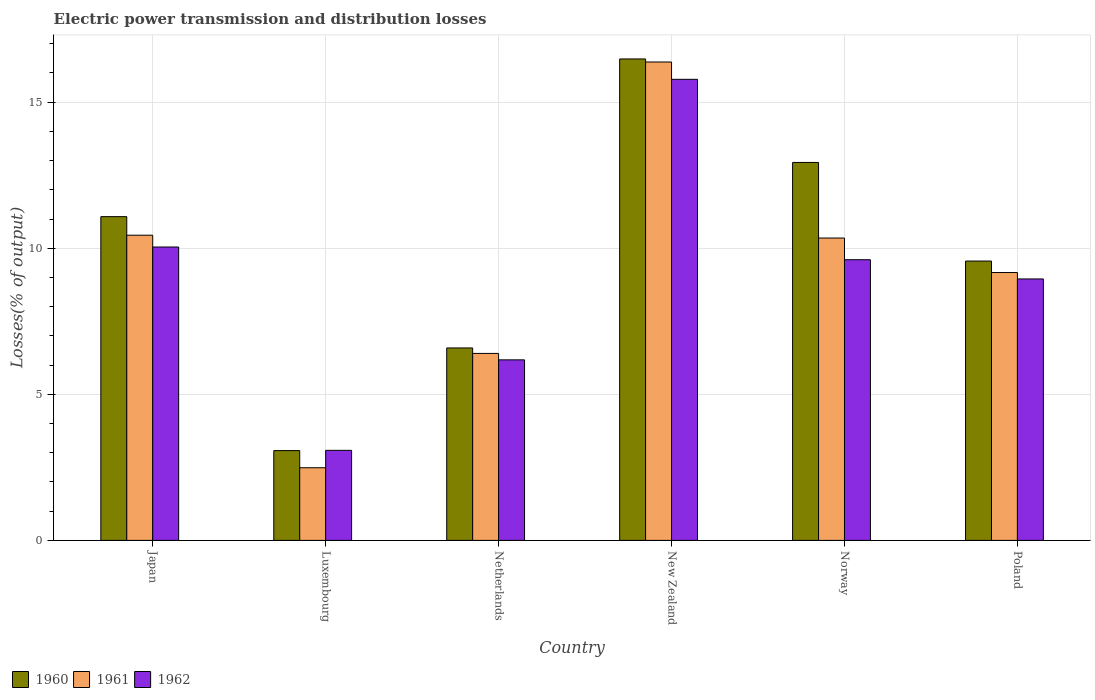How many different coloured bars are there?
Your answer should be compact. 3. How many groups of bars are there?
Make the answer very short. 6. Are the number of bars per tick equal to the number of legend labels?
Your response must be concise. Yes. How many bars are there on the 2nd tick from the left?
Ensure brevity in your answer.  3. How many bars are there on the 2nd tick from the right?
Your answer should be very brief. 3. What is the label of the 3rd group of bars from the left?
Your response must be concise. Netherlands. In how many cases, is the number of bars for a given country not equal to the number of legend labels?
Offer a very short reply. 0. What is the electric power transmission and distribution losses in 1962 in Luxembourg?
Make the answer very short. 3.08. Across all countries, what is the maximum electric power transmission and distribution losses in 1960?
Provide a succinct answer. 16.48. Across all countries, what is the minimum electric power transmission and distribution losses in 1961?
Your response must be concise. 2.49. In which country was the electric power transmission and distribution losses in 1960 maximum?
Your answer should be very brief. New Zealand. In which country was the electric power transmission and distribution losses in 1961 minimum?
Your answer should be very brief. Luxembourg. What is the total electric power transmission and distribution losses in 1962 in the graph?
Offer a terse response. 53.65. What is the difference between the electric power transmission and distribution losses in 1961 in Japan and that in Netherlands?
Keep it short and to the point. 4.05. What is the difference between the electric power transmission and distribution losses in 1961 in Norway and the electric power transmission and distribution losses in 1962 in Poland?
Offer a very short reply. 1.4. What is the average electric power transmission and distribution losses in 1961 per country?
Provide a succinct answer. 9.2. What is the difference between the electric power transmission and distribution losses of/in 1962 and electric power transmission and distribution losses of/in 1961 in Japan?
Your response must be concise. -0.4. What is the ratio of the electric power transmission and distribution losses in 1961 in Japan to that in Poland?
Give a very brief answer. 1.14. Is the electric power transmission and distribution losses in 1961 in Japan less than that in Netherlands?
Your answer should be very brief. No. What is the difference between the highest and the second highest electric power transmission and distribution losses in 1961?
Offer a terse response. 5.93. What is the difference between the highest and the lowest electric power transmission and distribution losses in 1960?
Give a very brief answer. 13.41. What does the 1st bar from the left in New Zealand represents?
Provide a succinct answer. 1960. What does the 1st bar from the right in New Zealand represents?
Keep it short and to the point. 1962. How many bars are there?
Keep it short and to the point. 18. How many countries are there in the graph?
Offer a terse response. 6. What is the difference between two consecutive major ticks on the Y-axis?
Make the answer very short. 5. Are the values on the major ticks of Y-axis written in scientific E-notation?
Your response must be concise. No. Does the graph contain grids?
Give a very brief answer. Yes. What is the title of the graph?
Your answer should be very brief. Electric power transmission and distribution losses. Does "1999" appear as one of the legend labels in the graph?
Your answer should be very brief. No. What is the label or title of the Y-axis?
Your answer should be compact. Losses(% of output). What is the Losses(% of output) of 1960 in Japan?
Your answer should be very brief. 11.08. What is the Losses(% of output) in 1961 in Japan?
Ensure brevity in your answer.  10.45. What is the Losses(% of output) in 1962 in Japan?
Your response must be concise. 10.04. What is the Losses(% of output) of 1960 in Luxembourg?
Your answer should be compact. 3.07. What is the Losses(% of output) of 1961 in Luxembourg?
Your answer should be very brief. 2.49. What is the Losses(% of output) of 1962 in Luxembourg?
Provide a succinct answer. 3.08. What is the Losses(% of output) in 1960 in Netherlands?
Your response must be concise. 6.59. What is the Losses(% of output) of 1961 in Netherlands?
Provide a succinct answer. 6.4. What is the Losses(% of output) of 1962 in Netherlands?
Make the answer very short. 6.18. What is the Losses(% of output) in 1960 in New Zealand?
Make the answer very short. 16.48. What is the Losses(% of output) in 1961 in New Zealand?
Offer a terse response. 16.38. What is the Losses(% of output) in 1962 in New Zealand?
Provide a short and direct response. 15.78. What is the Losses(% of output) of 1960 in Norway?
Offer a very short reply. 12.94. What is the Losses(% of output) in 1961 in Norway?
Offer a terse response. 10.35. What is the Losses(% of output) of 1962 in Norway?
Your answer should be very brief. 9.61. What is the Losses(% of output) of 1960 in Poland?
Provide a succinct answer. 9.56. What is the Losses(% of output) in 1961 in Poland?
Your answer should be compact. 9.17. What is the Losses(% of output) of 1962 in Poland?
Keep it short and to the point. 8.95. Across all countries, what is the maximum Losses(% of output) in 1960?
Offer a terse response. 16.48. Across all countries, what is the maximum Losses(% of output) of 1961?
Your response must be concise. 16.38. Across all countries, what is the maximum Losses(% of output) in 1962?
Your answer should be very brief. 15.78. Across all countries, what is the minimum Losses(% of output) of 1960?
Keep it short and to the point. 3.07. Across all countries, what is the minimum Losses(% of output) of 1961?
Keep it short and to the point. 2.49. Across all countries, what is the minimum Losses(% of output) in 1962?
Your answer should be compact. 3.08. What is the total Losses(% of output) of 1960 in the graph?
Your answer should be compact. 59.72. What is the total Losses(% of output) in 1961 in the graph?
Make the answer very short. 55.23. What is the total Losses(% of output) in 1962 in the graph?
Provide a short and direct response. 53.65. What is the difference between the Losses(% of output) in 1960 in Japan and that in Luxembourg?
Offer a terse response. 8.01. What is the difference between the Losses(% of output) of 1961 in Japan and that in Luxembourg?
Your answer should be compact. 7.96. What is the difference between the Losses(% of output) in 1962 in Japan and that in Luxembourg?
Give a very brief answer. 6.96. What is the difference between the Losses(% of output) in 1960 in Japan and that in Netherlands?
Provide a succinct answer. 4.49. What is the difference between the Losses(% of output) of 1961 in Japan and that in Netherlands?
Offer a very short reply. 4.05. What is the difference between the Losses(% of output) in 1962 in Japan and that in Netherlands?
Make the answer very short. 3.86. What is the difference between the Losses(% of output) of 1960 in Japan and that in New Zealand?
Make the answer very short. -5.4. What is the difference between the Losses(% of output) in 1961 in Japan and that in New Zealand?
Keep it short and to the point. -5.93. What is the difference between the Losses(% of output) in 1962 in Japan and that in New Zealand?
Ensure brevity in your answer.  -5.74. What is the difference between the Losses(% of output) in 1960 in Japan and that in Norway?
Make the answer very short. -1.85. What is the difference between the Losses(% of output) of 1961 in Japan and that in Norway?
Give a very brief answer. 0.1. What is the difference between the Losses(% of output) of 1962 in Japan and that in Norway?
Give a very brief answer. 0.44. What is the difference between the Losses(% of output) in 1960 in Japan and that in Poland?
Your answer should be very brief. 1.52. What is the difference between the Losses(% of output) of 1961 in Japan and that in Poland?
Ensure brevity in your answer.  1.28. What is the difference between the Losses(% of output) of 1962 in Japan and that in Poland?
Keep it short and to the point. 1.09. What is the difference between the Losses(% of output) in 1960 in Luxembourg and that in Netherlands?
Ensure brevity in your answer.  -3.51. What is the difference between the Losses(% of output) in 1961 in Luxembourg and that in Netherlands?
Offer a terse response. -3.91. What is the difference between the Losses(% of output) of 1962 in Luxembourg and that in Netherlands?
Provide a succinct answer. -3.1. What is the difference between the Losses(% of output) in 1960 in Luxembourg and that in New Zealand?
Your answer should be compact. -13.41. What is the difference between the Losses(% of output) in 1961 in Luxembourg and that in New Zealand?
Offer a very short reply. -13.89. What is the difference between the Losses(% of output) in 1962 in Luxembourg and that in New Zealand?
Offer a terse response. -12.7. What is the difference between the Losses(% of output) of 1960 in Luxembourg and that in Norway?
Offer a terse response. -9.86. What is the difference between the Losses(% of output) of 1961 in Luxembourg and that in Norway?
Offer a terse response. -7.86. What is the difference between the Losses(% of output) of 1962 in Luxembourg and that in Norway?
Your answer should be very brief. -6.53. What is the difference between the Losses(% of output) of 1960 in Luxembourg and that in Poland?
Your answer should be very brief. -6.49. What is the difference between the Losses(% of output) of 1961 in Luxembourg and that in Poland?
Offer a terse response. -6.68. What is the difference between the Losses(% of output) in 1962 in Luxembourg and that in Poland?
Your answer should be very brief. -5.87. What is the difference between the Losses(% of output) in 1960 in Netherlands and that in New Zealand?
Your response must be concise. -9.89. What is the difference between the Losses(% of output) of 1961 in Netherlands and that in New Zealand?
Your answer should be very brief. -9.98. What is the difference between the Losses(% of output) of 1962 in Netherlands and that in New Zealand?
Give a very brief answer. -9.6. What is the difference between the Losses(% of output) in 1960 in Netherlands and that in Norway?
Make the answer very short. -6.35. What is the difference between the Losses(% of output) in 1961 in Netherlands and that in Norway?
Your answer should be compact. -3.95. What is the difference between the Losses(% of output) of 1962 in Netherlands and that in Norway?
Offer a very short reply. -3.43. What is the difference between the Losses(% of output) in 1960 in Netherlands and that in Poland?
Give a very brief answer. -2.97. What is the difference between the Losses(% of output) of 1961 in Netherlands and that in Poland?
Offer a very short reply. -2.77. What is the difference between the Losses(% of output) of 1962 in Netherlands and that in Poland?
Ensure brevity in your answer.  -2.77. What is the difference between the Losses(% of output) in 1960 in New Zealand and that in Norway?
Give a very brief answer. 3.54. What is the difference between the Losses(% of output) in 1961 in New Zealand and that in Norway?
Give a very brief answer. 6.03. What is the difference between the Losses(% of output) of 1962 in New Zealand and that in Norway?
Make the answer very short. 6.18. What is the difference between the Losses(% of output) of 1960 in New Zealand and that in Poland?
Your answer should be compact. 6.92. What is the difference between the Losses(% of output) of 1961 in New Zealand and that in Poland?
Offer a terse response. 7.21. What is the difference between the Losses(% of output) in 1962 in New Zealand and that in Poland?
Make the answer very short. 6.83. What is the difference between the Losses(% of output) in 1960 in Norway and that in Poland?
Offer a terse response. 3.38. What is the difference between the Losses(% of output) of 1961 in Norway and that in Poland?
Offer a terse response. 1.18. What is the difference between the Losses(% of output) in 1962 in Norway and that in Poland?
Offer a terse response. 0.66. What is the difference between the Losses(% of output) in 1960 in Japan and the Losses(% of output) in 1961 in Luxembourg?
Your answer should be very brief. 8.6. What is the difference between the Losses(% of output) of 1960 in Japan and the Losses(% of output) of 1962 in Luxembourg?
Give a very brief answer. 8. What is the difference between the Losses(% of output) in 1961 in Japan and the Losses(% of output) in 1962 in Luxembourg?
Offer a terse response. 7.36. What is the difference between the Losses(% of output) in 1960 in Japan and the Losses(% of output) in 1961 in Netherlands?
Offer a very short reply. 4.68. What is the difference between the Losses(% of output) in 1960 in Japan and the Losses(% of output) in 1962 in Netherlands?
Offer a very short reply. 4.9. What is the difference between the Losses(% of output) of 1961 in Japan and the Losses(% of output) of 1962 in Netherlands?
Keep it short and to the point. 4.27. What is the difference between the Losses(% of output) of 1960 in Japan and the Losses(% of output) of 1961 in New Zealand?
Your response must be concise. -5.29. What is the difference between the Losses(% of output) in 1960 in Japan and the Losses(% of output) in 1962 in New Zealand?
Provide a short and direct response. -4.7. What is the difference between the Losses(% of output) in 1961 in Japan and the Losses(% of output) in 1962 in New Zealand?
Your answer should be compact. -5.34. What is the difference between the Losses(% of output) in 1960 in Japan and the Losses(% of output) in 1961 in Norway?
Offer a terse response. 0.73. What is the difference between the Losses(% of output) in 1960 in Japan and the Losses(% of output) in 1962 in Norway?
Give a very brief answer. 1.47. What is the difference between the Losses(% of output) in 1961 in Japan and the Losses(% of output) in 1962 in Norway?
Provide a short and direct response. 0.84. What is the difference between the Losses(% of output) of 1960 in Japan and the Losses(% of output) of 1961 in Poland?
Offer a terse response. 1.91. What is the difference between the Losses(% of output) of 1960 in Japan and the Losses(% of output) of 1962 in Poland?
Give a very brief answer. 2.13. What is the difference between the Losses(% of output) in 1961 in Japan and the Losses(% of output) in 1962 in Poland?
Your response must be concise. 1.5. What is the difference between the Losses(% of output) of 1960 in Luxembourg and the Losses(% of output) of 1961 in Netherlands?
Provide a succinct answer. -3.33. What is the difference between the Losses(% of output) in 1960 in Luxembourg and the Losses(% of output) in 1962 in Netherlands?
Give a very brief answer. -3.11. What is the difference between the Losses(% of output) in 1961 in Luxembourg and the Losses(% of output) in 1962 in Netherlands?
Ensure brevity in your answer.  -3.69. What is the difference between the Losses(% of output) in 1960 in Luxembourg and the Losses(% of output) in 1961 in New Zealand?
Keep it short and to the point. -13.3. What is the difference between the Losses(% of output) in 1960 in Luxembourg and the Losses(% of output) in 1962 in New Zealand?
Make the answer very short. -12.71. What is the difference between the Losses(% of output) in 1961 in Luxembourg and the Losses(% of output) in 1962 in New Zealand?
Provide a succinct answer. -13.3. What is the difference between the Losses(% of output) of 1960 in Luxembourg and the Losses(% of output) of 1961 in Norway?
Provide a short and direct response. -7.28. What is the difference between the Losses(% of output) of 1960 in Luxembourg and the Losses(% of output) of 1962 in Norway?
Provide a short and direct response. -6.53. What is the difference between the Losses(% of output) in 1961 in Luxembourg and the Losses(% of output) in 1962 in Norway?
Your answer should be compact. -7.12. What is the difference between the Losses(% of output) of 1960 in Luxembourg and the Losses(% of output) of 1961 in Poland?
Give a very brief answer. -6.09. What is the difference between the Losses(% of output) in 1960 in Luxembourg and the Losses(% of output) in 1962 in Poland?
Keep it short and to the point. -5.88. What is the difference between the Losses(% of output) in 1961 in Luxembourg and the Losses(% of output) in 1962 in Poland?
Give a very brief answer. -6.46. What is the difference between the Losses(% of output) in 1960 in Netherlands and the Losses(% of output) in 1961 in New Zealand?
Give a very brief answer. -9.79. What is the difference between the Losses(% of output) in 1960 in Netherlands and the Losses(% of output) in 1962 in New Zealand?
Provide a short and direct response. -9.2. What is the difference between the Losses(% of output) in 1961 in Netherlands and the Losses(% of output) in 1962 in New Zealand?
Offer a terse response. -9.38. What is the difference between the Losses(% of output) in 1960 in Netherlands and the Losses(% of output) in 1961 in Norway?
Offer a terse response. -3.76. What is the difference between the Losses(% of output) of 1960 in Netherlands and the Losses(% of output) of 1962 in Norway?
Give a very brief answer. -3.02. What is the difference between the Losses(% of output) in 1961 in Netherlands and the Losses(% of output) in 1962 in Norway?
Provide a short and direct response. -3.21. What is the difference between the Losses(% of output) of 1960 in Netherlands and the Losses(% of output) of 1961 in Poland?
Provide a short and direct response. -2.58. What is the difference between the Losses(% of output) in 1960 in Netherlands and the Losses(% of output) in 1962 in Poland?
Provide a short and direct response. -2.36. What is the difference between the Losses(% of output) of 1961 in Netherlands and the Losses(% of output) of 1962 in Poland?
Your answer should be compact. -2.55. What is the difference between the Losses(% of output) of 1960 in New Zealand and the Losses(% of output) of 1961 in Norway?
Ensure brevity in your answer.  6.13. What is the difference between the Losses(% of output) of 1960 in New Zealand and the Losses(% of output) of 1962 in Norway?
Make the answer very short. 6.87. What is the difference between the Losses(% of output) of 1961 in New Zealand and the Losses(% of output) of 1962 in Norway?
Offer a very short reply. 6.77. What is the difference between the Losses(% of output) in 1960 in New Zealand and the Losses(% of output) in 1961 in Poland?
Make the answer very short. 7.31. What is the difference between the Losses(% of output) in 1960 in New Zealand and the Losses(% of output) in 1962 in Poland?
Your answer should be compact. 7.53. What is the difference between the Losses(% of output) in 1961 in New Zealand and the Losses(% of output) in 1962 in Poland?
Offer a very short reply. 7.43. What is the difference between the Losses(% of output) in 1960 in Norway and the Losses(% of output) in 1961 in Poland?
Your response must be concise. 3.77. What is the difference between the Losses(% of output) of 1960 in Norway and the Losses(% of output) of 1962 in Poland?
Keep it short and to the point. 3.99. What is the difference between the Losses(% of output) of 1961 in Norway and the Losses(% of output) of 1962 in Poland?
Give a very brief answer. 1.4. What is the average Losses(% of output) in 1960 per country?
Your answer should be compact. 9.95. What is the average Losses(% of output) of 1961 per country?
Ensure brevity in your answer.  9.2. What is the average Losses(% of output) in 1962 per country?
Provide a succinct answer. 8.94. What is the difference between the Losses(% of output) of 1960 and Losses(% of output) of 1961 in Japan?
Make the answer very short. 0.64. What is the difference between the Losses(% of output) in 1960 and Losses(% of output) in 1962 in Japan?
Provide a succinct answer. 1.04. What is the difference between the Losses(% of output) in 1961 and Losses(% of output) in 1962 in Japan?
Ensure brevity in your answer.  0.4. What is the difference between the Losses(% of output) of 1960 and Losses(% of output) of 1961 in Luxembourg?
Ensure brevity in your answer.  0.59. What is the difference between the Losses(% of output) in 1960 and Losses(% of output) in 1962 in Luxembourg?
Provide a succinct answer. -0.01. What is the difference between the Losses(% of output) in 1961 and Losses(% of output) in 1962 in Luxembourg?
Offer a terse response. -0.6. What is the difference between the Losses(% of output) of 1960 and Losses(% of output) of 1961 in Netherlands?
Your response must be concise. 0.19. What is the difference between the Losses(% of output) in 1960 and Losses(% of output) in 1962 in Netherlands?
Your answer should be compact. 0.41. What is the difference between the Losses(% of output) of 1961 and Losses(% of output) of 1962 in Netherlands?
Ensure brevity in your answer.  0.22. What is the difference between the Losses(% of output) of 1960 and Losses(% of output) of 1961 in New Zealand?
Your answer should be compact. 0.1. What is the difference between the Losses(% of output) in 1960 and Losses(% of output) in 1962 in New Zealand?
Offer a very short reply. 0.7. What is the difference between the Losses(% of output) in 1961 and Losses(% of output) in 1962 in New Zealand?
Give a very brief answer. 0.59. What is the difference between the Losses(% of output) in 1960 and Losses(% of output) in 1961 in Norway?
Provide a succinct answer. 2.59. What is the difference between the Losses(% of output) in 1960 and Losses(% of output) in 1962 in Norway?
Provide a short and direct response. 3.33. What is the difference between the Losses(% of output) of 1961 and Losses(% of output) of 1962 in Norway?
Offer a very short reply. 0.74. What is the difference between the Losses(% of output) in 1960 and Losses(% of output) in 1961 in Poland?
Offer a very short reply. 0.39. What is the difference between the Losses(% of output) of 1960 and Losses(% of output) of 1962 in Poland?
Your answer should be compact. 0.61. What is the difference between the Losses(% of output) in 1961 and Losses(% of output) in 1962 in Poland?
Offer a terse response. 0.22. What is the ratio of the Losses(% of output) in 1960 in Japan to that in Luxembourg?
Your answer should be compact. 3.61. What is the ratio of the Losses(% of output) of 1961 in Japan to that in Luxembourg?
Make the answer very short. 4.2. What is the ratio of the Losses(% of output) of 1962 in Japan to that in Luxembourg?
Your answer should be compact. 3.26. What is the ratio of the Losses(% of output) of 1960 in Japan to that in Netherlands?
Ensure brevity in your answer.  1.68. What is the ratio of the Losses(% of output) in 1961 in Japan to that in Netherlands?
Keep it short and to the point. 1.63. What is the ratio of the Losses(% of output) in 1962 in Japan to that in Netherlands?
Offer a very short reply. 1.62. What is the ratio of the Losses(% of output) in 1960 in Japan to that in New Zealand?
Provide a short and direct response. 0.67. What is the ratio of the Losses(% of output) in 1961 in Japan to that in New Zealand?
Ensure brevity in your answer.  0.64. What is the ratio of the Losses(% of output) of 1962 in Japan to that in New Zealand?
Keep it short and to the point. 0.64. What is the ratio of the Losses(% of output) in 1960 in Japan to that in Norway?
Provide a short and direct response. 0.86. What is the ratio of the Losses(% of output) of 1961 in Japan to that in Norway?
Your response must be concise. 1.01. What is the ratio of the Losses(% of output) in 1962 in Japan to that in Norway?
Give a very brief answer. 1.05. What is the ratio of the Losses(% of output) in 1960 in Japan to that in Poland?
Give a very brief answer. 1.16. What is the ratio of the Losses(% of output) of 1961 in Japan to that in Poland?
Ensure brevity in your answer.  1.14. What is the ratio of the Losses(% of output) of 1962 in Japan to that in Poland?
Provide a succinct answer. 1.12. What is the ratio of the Losses(% of output) in 1960 in Luxembourg to that in Netherlands?
Keep it short and to the point. 0.47. What is the ratio of the Losses(% of output) of 1961 in Luxembourg to that in Netherlands?
Your answer should be compact. 0.39. What is the ratio of the Losses(% of output) in 1962 in Luxembourg to that in Netherlands?
Keep it short and to the point. 0.5. What is the ratio of the Losses(% of output) in 1960 in Luxembourg to that in New Zealand?
Provide a short and direct response. 0.19. What is the ratio of the Losses(% of output) in 1961 in Luxembourg to that in New Zealand?
Ensure brevity in your answer.  0.15. What is the ratio of the Losses(% of output) of 1962 in Luxembourg to that in New Zealand?
Provide a short and direct response. 0.2. What is the ratio of the Losses(% of output) of 1960 in Luxembourg to that in Norway?
Keep it short and to the point. 0.24. What is the ratio of the Losses(% of output) in 1961 in Luxembourg to that in Norway?
Offer a terse response. 0.24. What is the ratio of the Losses(% of output) in 1962 in Luxembourg to that in Norway?
Your response must be concise. 0.32. What is the ratio of the Losses(% of output) of 1960 in Luxembourg to that in Poland?
Offer a very short reply. 0.32. What is the ratio of the Losses(% of output) of 1961 in Luxembourg to that in Poland?
Provide a succinct answer. 0.27. What is the ratio of the Losses(% of output) of 1962 in Luxembourg to that in Poland?
Ensure brevity in your answer.  0.34. What is the ratio of the Losses(% of output) of 1960 in Netherlands to that in New Zealand?
Ensure brevity in your answer.  0.4. What is the ratio of the Losses(% of output) in 1961 in Netherlands to that in New Zealand?
Provide a short and direct response. 0.39. What is the ratio of the Losses(% of output) of 1962 in Netherlands to that in New Zealand?
Offer a terse response. 0.39. What is the ratio of the Losses(% of output) in 1960 in Netherlands to that in Norway?
Make the answer very short. 0.51. What is the ratio of the Losses(% of output) in 1961 in Netherlands to that in Norway?
Give a very brief answer. 0.62. What is the ratio of the Losses(% of output) of 1962 in Netherlands to that in Norway?
Provide a short and direct response. 0.64. What is the ratio of the Losses(% of output) in 1960 in Netherlands to that in Poland?
Your answer should be compact. 0.69. What is the ratio of the Losses(% of output) in 1961 in Netherlands to that in Poland?
Your response must be concise. 0.7. What is the ratio of the Losses(% of output) of 1962 in Netherlands to that in Poland?
Your answer should be compact. 0.69. What is the ratio of the Losses(% of output) in 1960 in New Zealand to that in Norway?
Your response must be concise. 1.27. What is the ratio of the Losses(% of output) in 1961 in New Zealand to that in Norway?
Ensure brevity in your answer.  1.58. What is the ratio of the Losses(% of output) in 1962 in New Zealand to that in Norway?
Your answer should be compact. 1.64. What is the ratio of the Losses(% of output) of 1960 in New Zealand to that in Poland?
Provide a succinct answer. 1.72. What is the ratio of the Losses(% of output) of 1961 in New Zealand to that in Poland?
Offer a terse response. 1.79. What is the ratio of the Losses(% of output) of 1962 in New Zealand to that in Poland?
Your answer should be compact. 1.76. What is the ratio of the Losses(% of output) of 1960 in Norway to that in Poland?
Give a very brief answer. 1.35. What is the ratio of the Losses(% of output) of 1961 in Norway to that in Poland?
Your answer should be very brief. 1.13. What is the ratio of the Losses(% of output) in 1962 in Norway to that in Poland?
Offer a terse response. 1.07. What is the difference between the highest and the second highest Losses(% of output) of 1960?
Provide a succinct answer. 3.54. What is the difference between the highest and the second highest Losses(% of output) in 1961?
Provide a succinct answer. 5.93. What is the difference between the highest and the second highest Losses(% of output) in 1962?
Provide a succinct answer. 5.74. What is the difference between the highest and the lowest Losses(% of output) in 1960?
Your answer should be very brief. 13.41. What is the difference between the highest and the lowest Losses(% of output) in 1961?
Ensure brevity in your answer.  13.89. What is the difference between the highest and the lowest Losses(% of output) in 1962?
Your response must be concise. 12.7. 